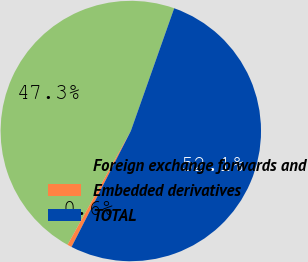<chart> <loc_0><loc_0><loc_500><loc_500><pie_chart><fcel>Foreign exchange forwards and<fcel>Embedded derivatives<fcel>TOTAL<nl><fcel>47.33%<fcel>0.55%<fcel>52.12%<nl></chart> 